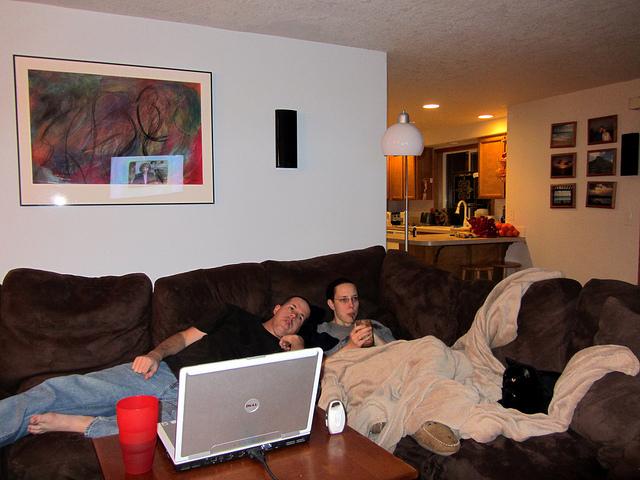Is the lamp above them turned on?
Give a very brief answer. No. Are they watching TV?
Answer briefly. Yes. Is that a laptop on the table?
Be succinct. Yes. What is the brand of computers in the photo?
Give a very brief answer. Dell. 